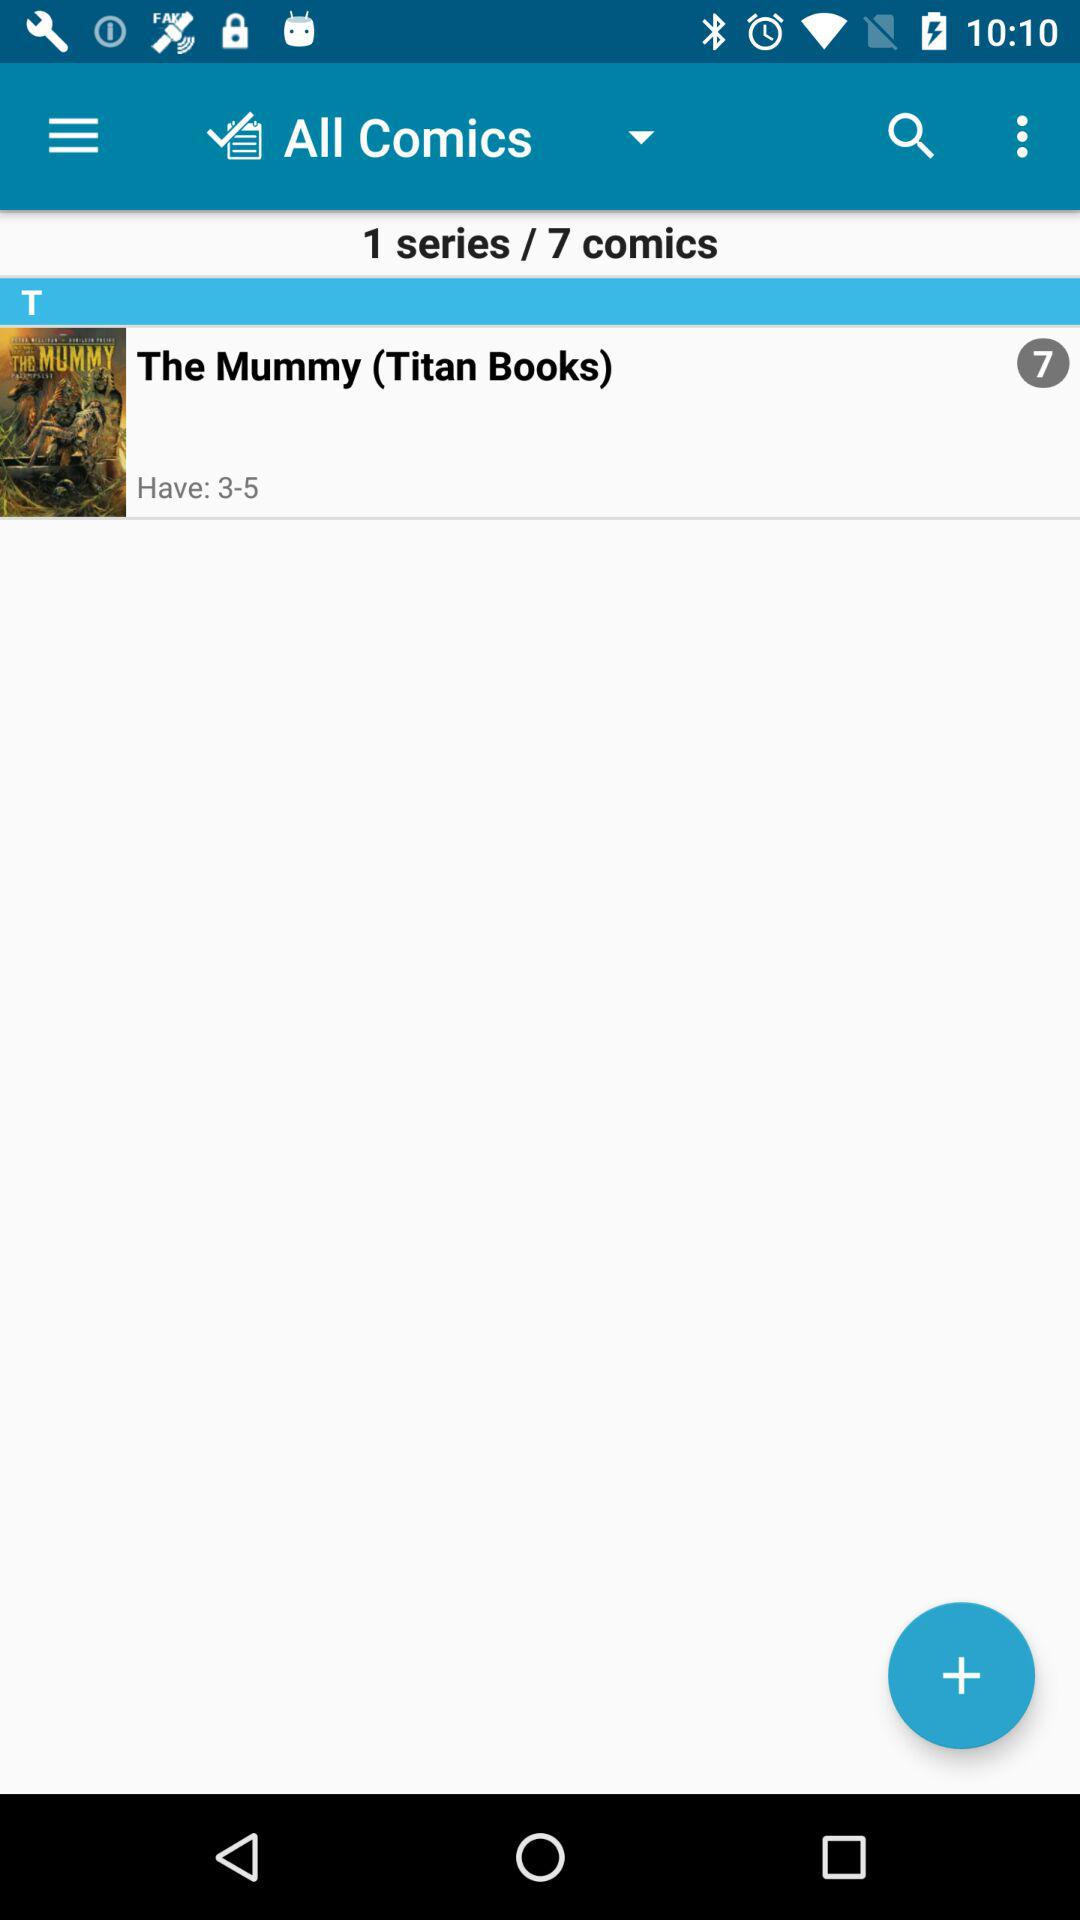What's the publisher name of "The Mummy" comic book? The publisher's name is "Titan Books". 